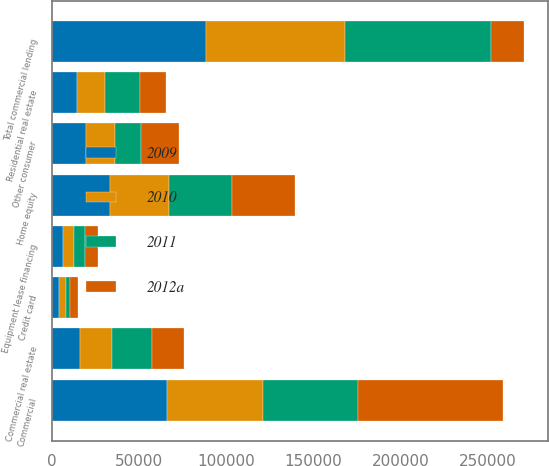<chart> <loc_0><loc_0><loc_500><loc_500><stacked_bar_chart><ecel><fcel>Commercial<fcel>Commercial real estate<fcel>Equipment lease financing<fcel>Total commercial lending<fcel>Home equity<fcel>Residential real estate<fcel>Credit card<fcel>Other consumer<nl><fcel>2012a<fcel>83040<fcel>18655<fcel>7247<fcel>18655<fcel>35920<fcel>15240<fcel>4303<fcel>21451<nl><fcel>2009<fcel>65694<fcel>16204<fcel>6416<fcel>88314<fcel>33089<fcel>14469<fcel>3976<fcel>19166<nl><fcel>2010<fcel>55177<fcel>17934<fcel>6393<fcel>79504<fcel>34226<fcel>15999<fcel>3920<fcel>16946<nl><fcel>2011<fcel>54818<fcel>23131<fcel>6202<fcel>84151<fcel>35947<fcel>19810<fcel>2569<fcel>15066<nl></chart> 